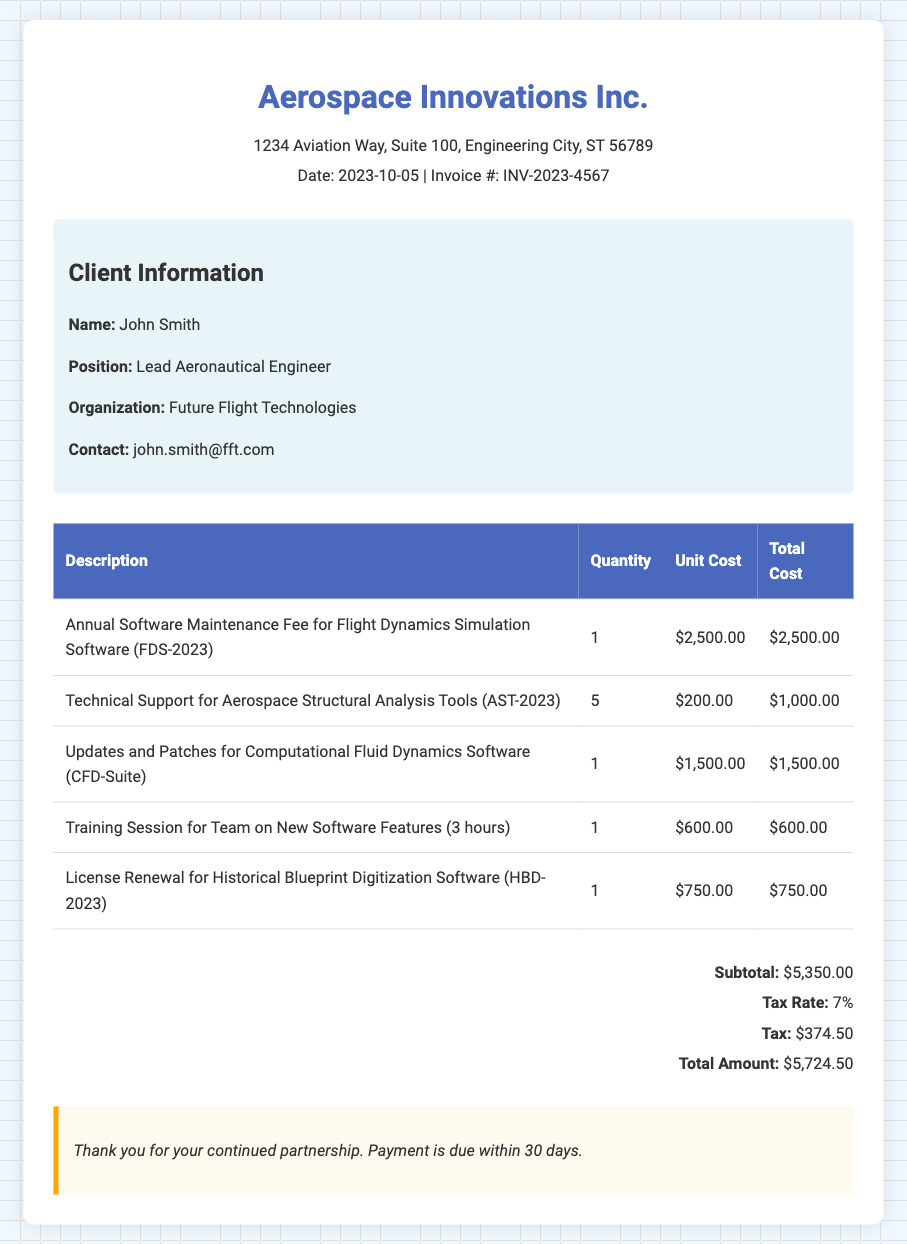what is the invoice number? The invoice number is listed in the header section of the document as INV-2023-4567.
Answer: INV-2023-4567 what is the name of the client? The client's name is provided in the client information section as John Smith.
Answer: John Smith how much is the annual software maintenance fee? The annual software maintenance fee is detailed in the itemized costs as $2,500.00.
Answer: $2,500.00 what is the total amount due? The total amount due is indicated at the bottom of the bill as $5,724.50.
Answer: $5,724.50 how many training sessions are included in the bill? The training session is mentioned as one session for team training on new software features.
Answer: 1 